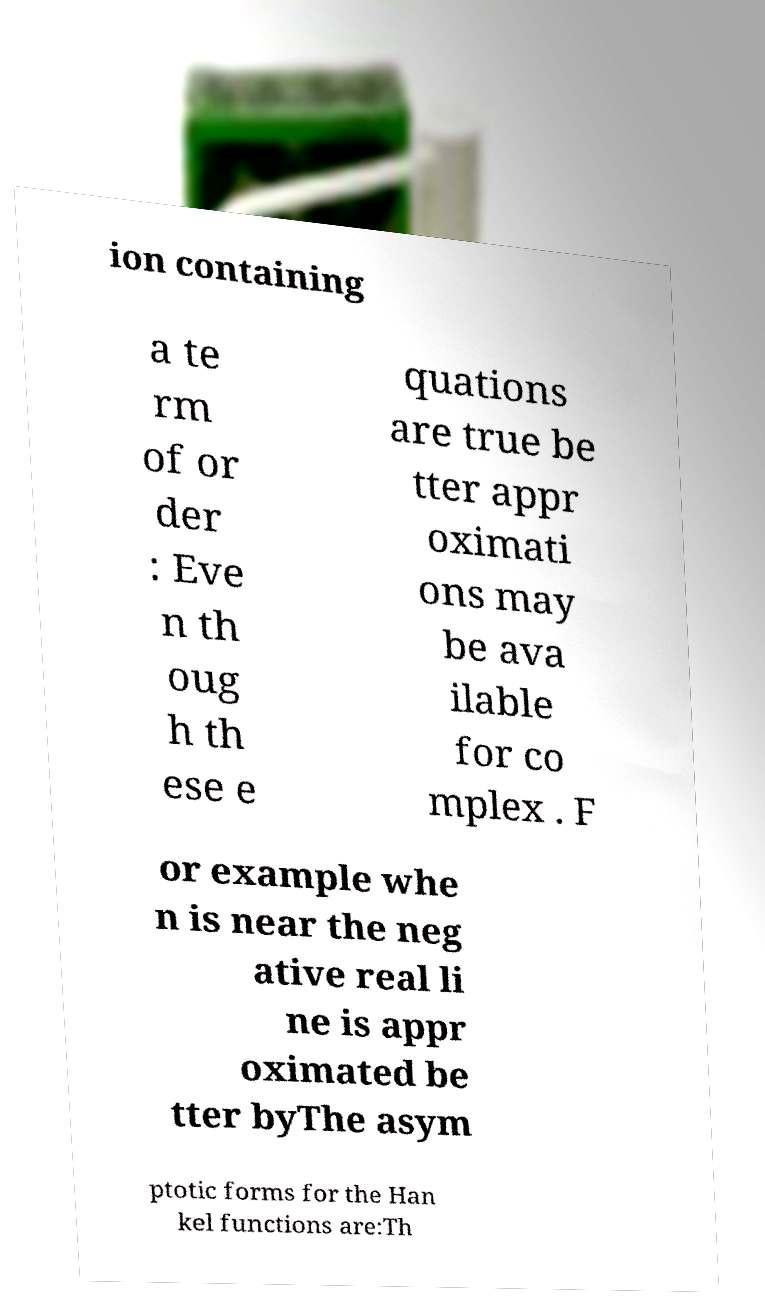Could you assist in decoding the text presented in this image and type it out clearly? ion containing a te rm of or der : Eve n th oug h th ese e quations are true be tter appr oximati ons may be ava ilable for co mplex . F or example whe n is near the neg ative real li ne is appr oximated be tter byThe asym ptotic forms for the Han kel functions are:Th 